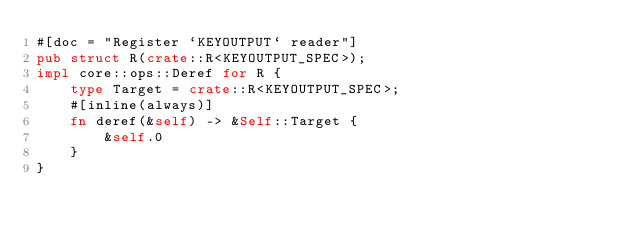<code> <loc_0><loc_0><loc_500><loc_500><_Rust_>#[doc = "Register `KEYOUTPUT` reader"]
pub struct R(crate::R<KEYOUTPUT_SPEC>);
impl core::ops::Deref for R {
    type Target = crate::R<KEYOUTPUT_SPEC>;
    #[inline(always)]
    fn deref(&self) -> &Self::Target {
        &self.0
    }
}</code> 